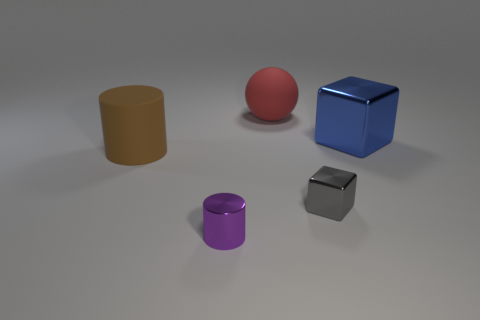If these objects had to be sorted by size, how would you categorize them? To sort them by size, starting with the largest, I'd arrange them as follows: the blue cube, the brown cylinder, the red sphere, the purple cylinder, and finally the small gray cube. 